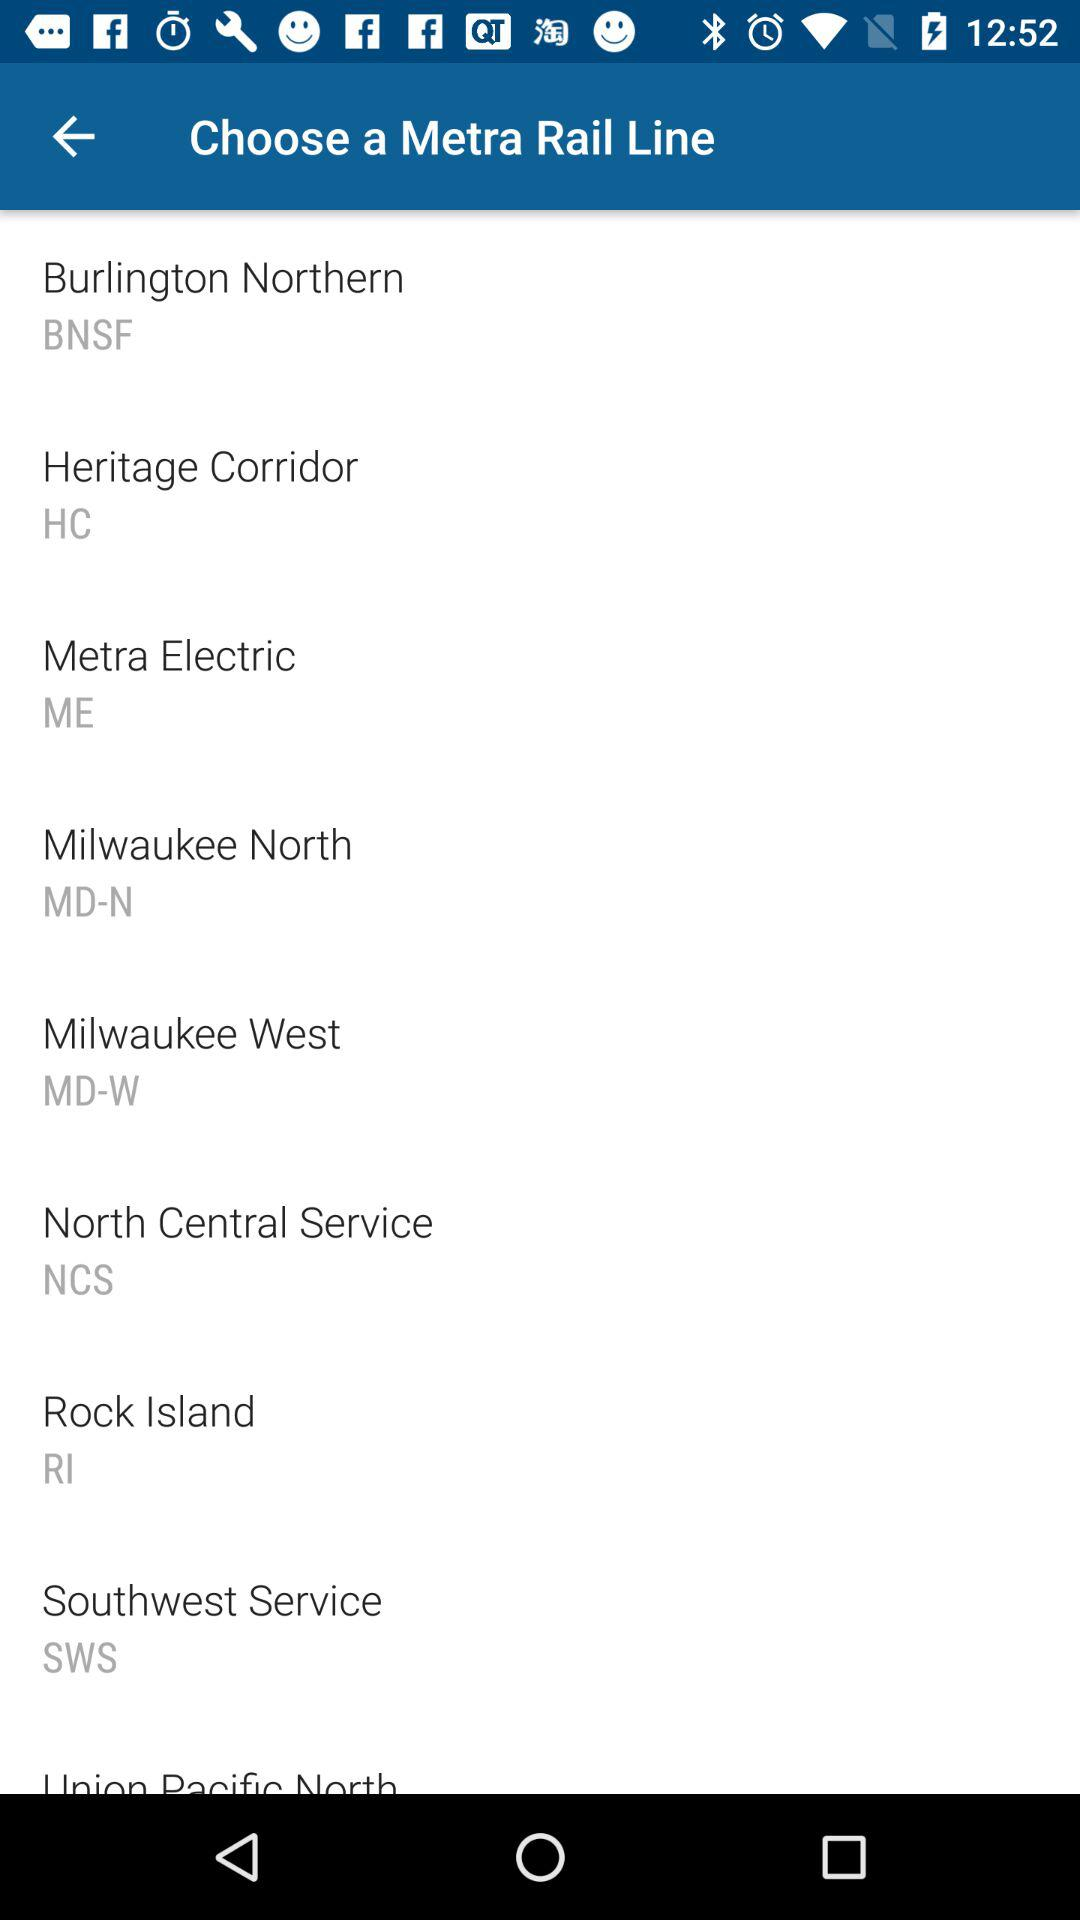What is the Metra rail line station code for "Rock Island"? The station code is RI. 